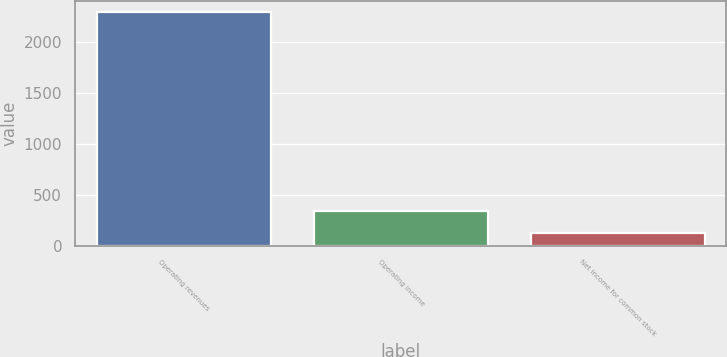Convert chart to OTSL. <chart><loc_0><loc_0><loc_500><loc_500><bar_chart><fcel>Operating revenues<fcel>Operating income<fcel>Net income for common stock<nl><fcel>2294<fcel>338.3<fcel>121<nl></chart> 